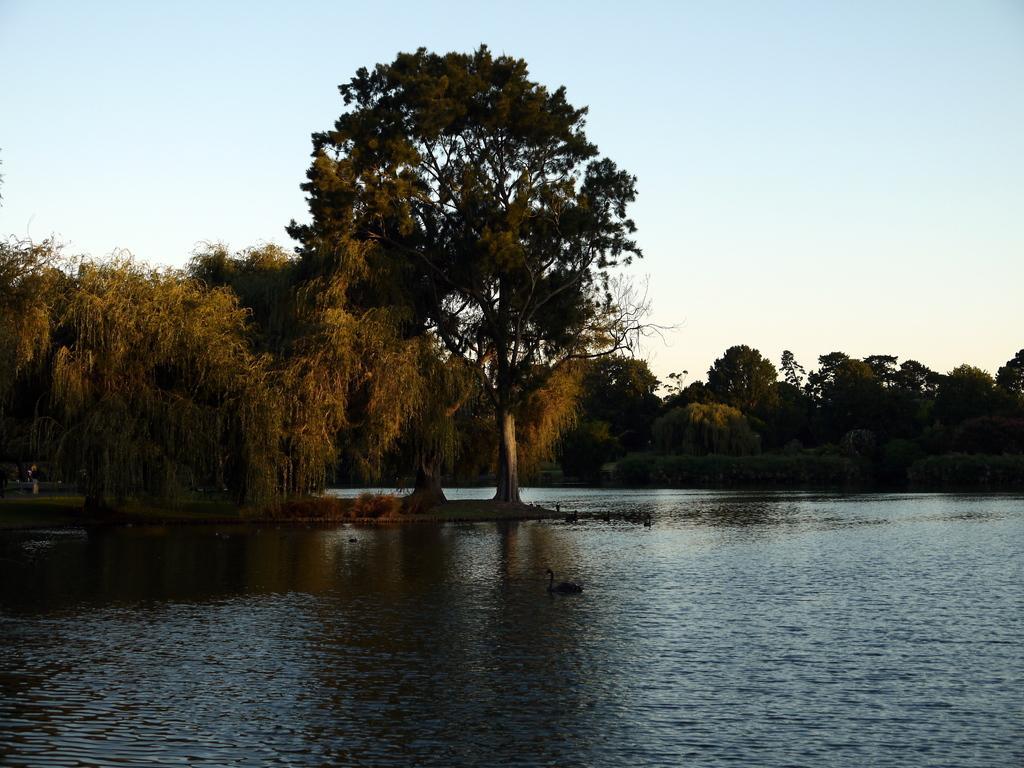Can you describe this image briefly? In this image we can see ducks swimming in the water, trees and the sky in the background. 